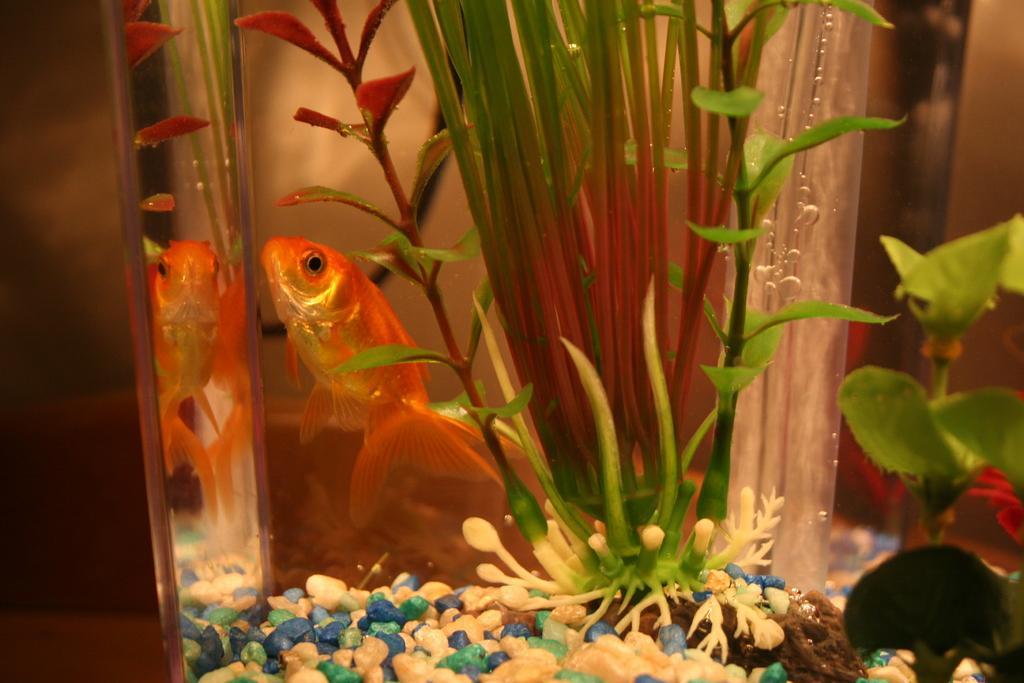Could you give a brief overview of what you see in this image? In this image we can see the aquarium. In the aquarium there are plants, stones and a fish. 